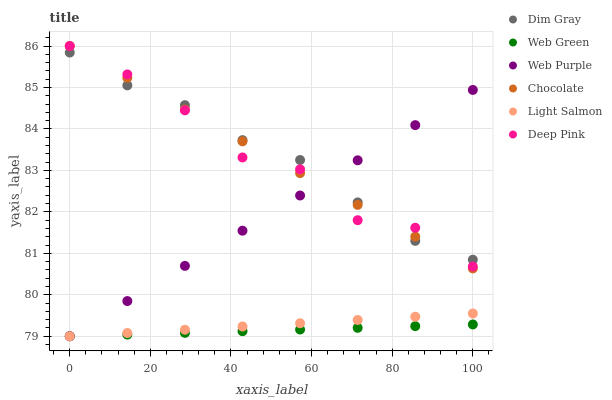Does Web Green have the minimum area under the curve?
Answer yes or no. Yes. Does Dim Gray have the maximum area under the curve?
Answer yes or no. Yes. Does Deep Pink have the minimum area under the curve?
Answer yes or no. No. Does Deep Pink have the maximum area under the curve?
Answer yes or no. No. Is Web Green the smoothest?
Answer yes or no. Yes. Is Deep Pink the roughest?
Answer yes or no. Yes. Is Deep Pink the smoothest?
Answer yes or no. No. Is Web Green the roughest?
Answer yes or no. No. Does Light Salmon have the lowest value?
Answer yes or no. Yes. Does Deep Pink have the lowest value?
Answer yes or no. No. Does Chocolate have the highest value?
Answer yes or no. Yes. Does Web Green have the highest value?
Answer yes or no. No. Is Web Green less than Dim Gray?
Answer yes or no. Yes. Is Dim Gray greater than Light Salmon?
Answer yes or no. Yes. Does Dim Gray intersect Web Purple?
Answer yes or no. Yes. Is Dim Gray less than Web Purple?
Answer yes or no. No. Is Dim Gray greater than Web Purple?
Answer yes or no. No. Does Web Green intersect Dim Gray?
Answer yes or no. No. 